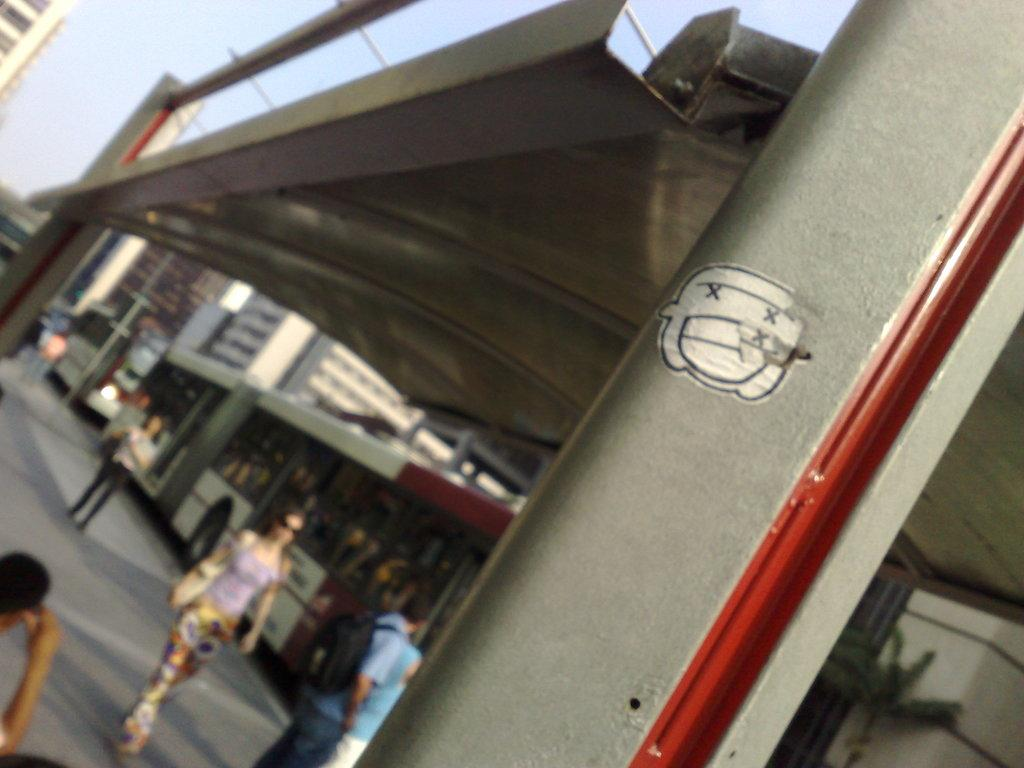What types of objects can be seen in the image? There are vehicles, pillars, and buildings in the image. Are there any living beings present in the image? Yes, there are people in the image. What can be seen in the background of the image? The sky is visible in the background of the image. How many snakes are slithering on the throne in the image? There are no snakes or thrones present in the image. What color is the orange in the image? There is no orange present in the image. 